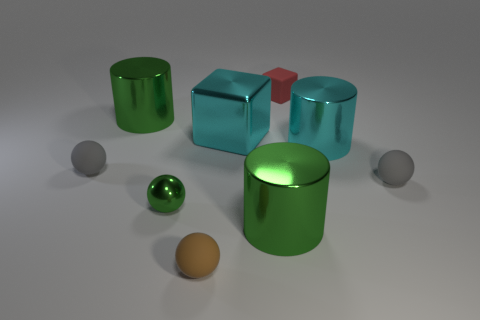Subtract 1 balls. How many balls are left? 3 Subtract all cyan cubes. Subtract all gray balls. How many cubes are left? 1 Subtract all blocks. How many objects are left? 7 Subtract all red rubber objects. Subtract all tiny brown matte balls. How many objects are left? 7 Add 1 big green things. How many big green things are left? 3 Add 5 tiny red objects. How many tiny red objects exist? 6 Subtract 0 blue cylinders. How many objects are left? 9 